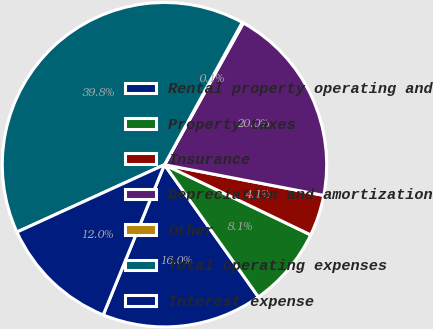Convert chart to OTSL. <chart><loc_0><loc_0><loc_500><loc_500><pie_chart><fcel>Rental property operating and<fcel>Property taxes<fcel>Insurance<fcel>Depreciation and amortization<fcel>Other<fcel>Total operating expenses<fcel>Interest expense<nl><fcel>15.99%<fcel>8.05%<fcel>4.09%<fcel>19.95%<fcel>0.12%<fcel>39.78%<fcel>12.02%<nl></chart> 